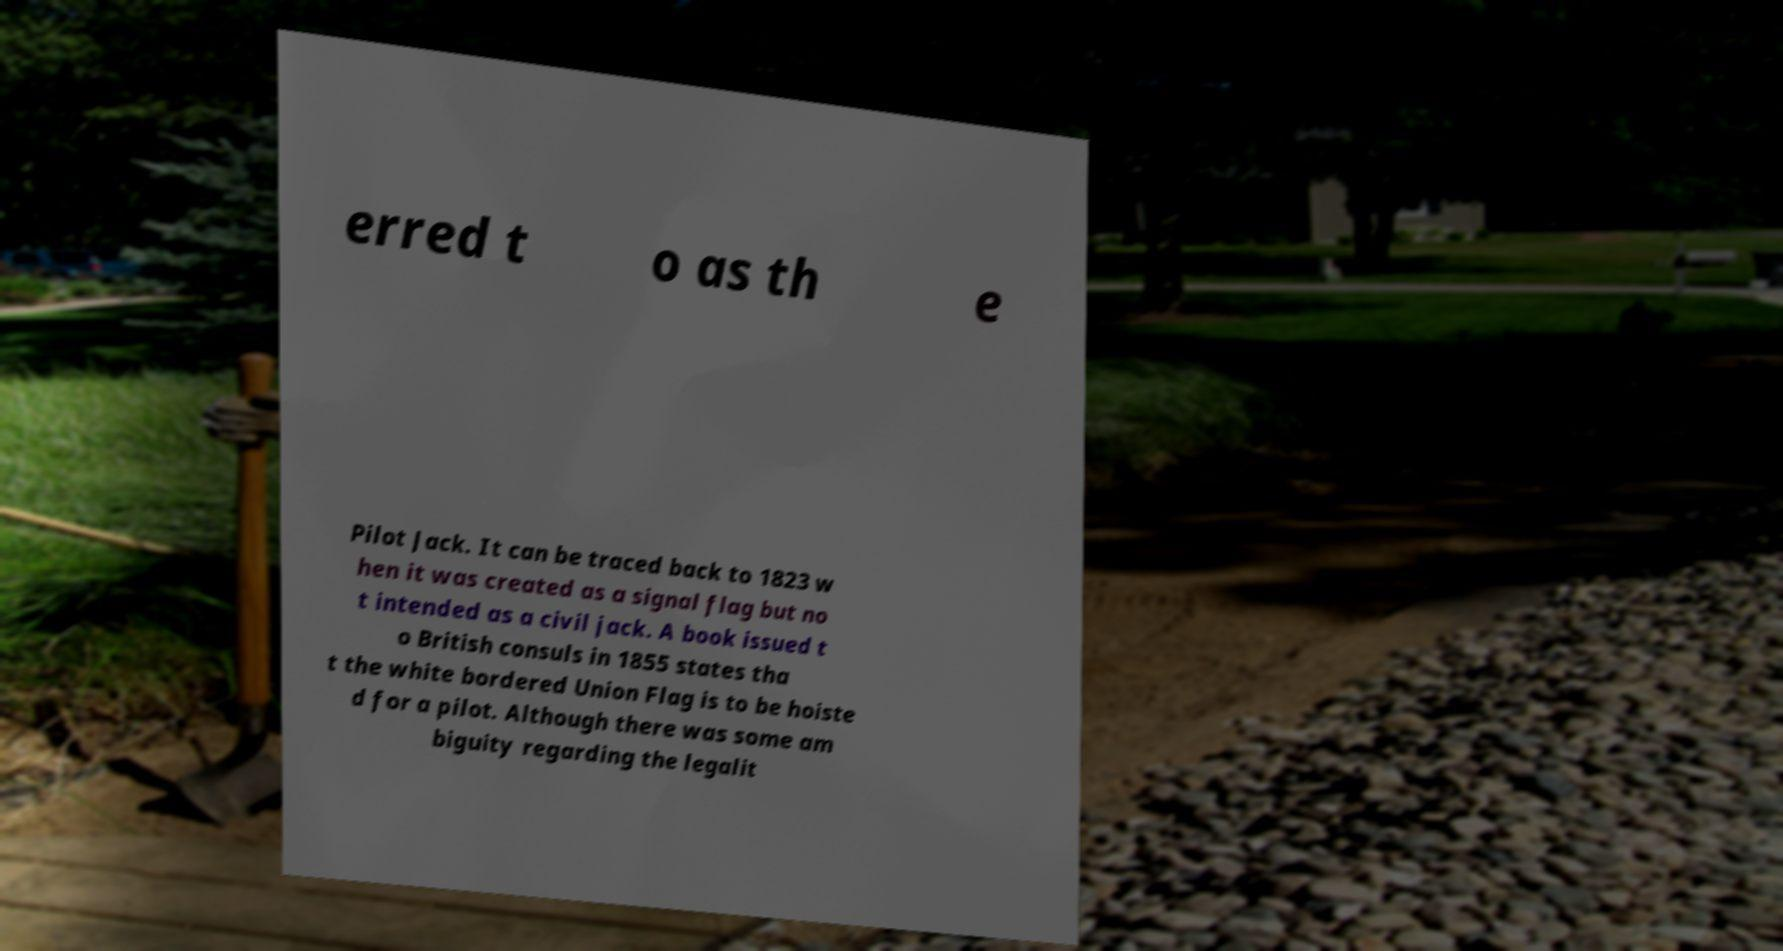Can you read and provide the text displayed in the image?This photo seems to have some interesting text. Can you extract and type it out for me? erred t o as th e Pilot Jack. It can be traced back to 1823 w hen it was created as a signal flag but no t intended as a civil jack. A book issued t o British consuls in 1855 states tha t the white bordered Union Flag is to be hoiste d for a pilot. Although there was some am biguity regarding the legalit 